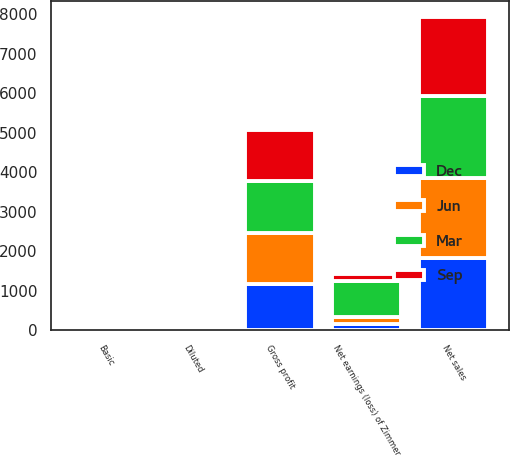<chart> <loc_0><loc_0><loc_500><loc_500><stacked_bar_chart><ecel><fcel>Net sales<fcel>Gross profit<fcel>Net earnings (loss) of Zimmer<fcel>Basic<fcel>Diluted<nl><fcel>Jun<fcel>2017.6<fcel>1291<fcel>174.7<fcel>0.86<fcel>0.85<nl><fcel>Sep<fcel>2007.6<fcel>1274.4<fcel>185<fcel>0.91<fcel>0.9<nl><fcel>Dec<fcel>1836.7<fcel>1160.1<fcel>162.2<fcel>0.8<fcel>0.79<nl><fcel>Mar<fcel>2071<fcel>1339.6<fcel>901.1<fcel>4.42<fcel>4.42<nl></chart> 